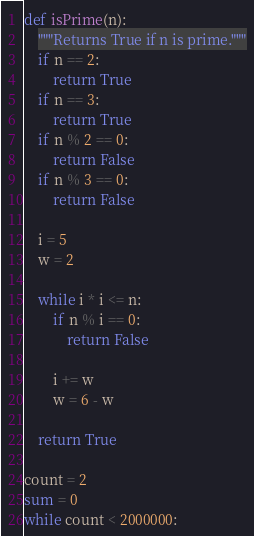<code> <loc_0><loc_0><loc_500><loc_500><_Python_>def isPrime(n):
    """Returns True if n is prime."""
    if n == 2:
        return True
    if n == 3:
        return True
    if n % 2 == 0:
        return False
    if n % 3 == 0:
        return False

    i = 5
    w = 2

    while i * i <= n:
        if n % i == 0:
            return False

        i += w
        w = 6 - w

    return True

count = 2
sum = 0
while count < 2000000:</code> 